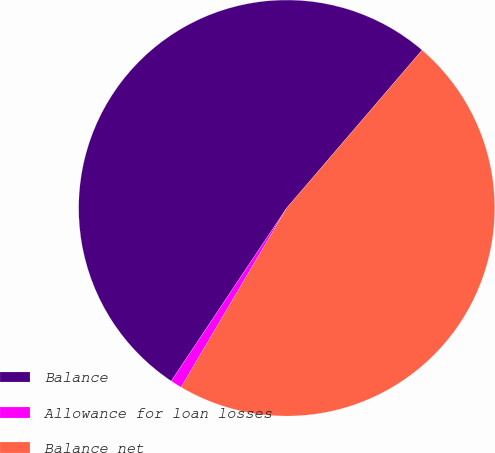Convert chart. <chart><loc_0><loc_0><loc_500><loc_500><pie_chart><fcel>Balance<fcel>Allowance for loan losses<fcel>Balance net<nl><fcel>51.91%<fcel>0.89%<fcel>47.19%<nl></chart> 